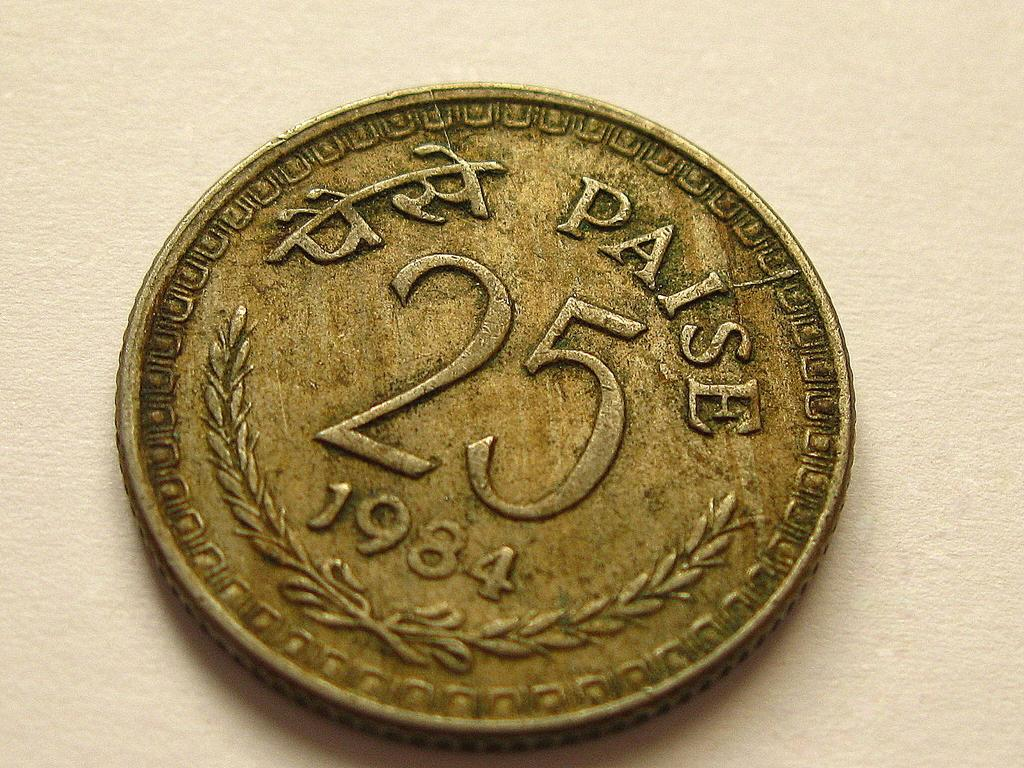<image>
Render a clear and concise summary of the photo. A dirty coin that says 25 Paise with the date 1984. 